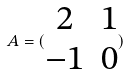<formula> <loc_0><loc_0><loc_500><loc_500>A = ( \begin{matrix} 2 & 1 \\ - 1 & 0 \end{matrix} )</formula> 